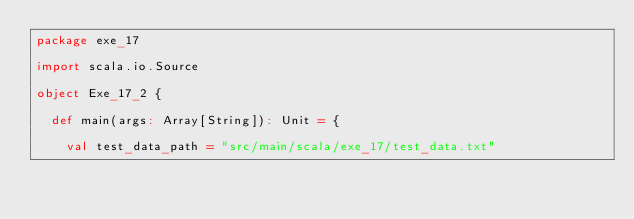Convert code to text. <code><loc_0><loc_0><loc_500><loc_500><_Scala_>package exe_17

import scala.io.Source

object Exe_17_2 {

  def main(args: Array[String]): Unit = {

    val test_data_path = "src/main/scala/exe_17/test_data.txt"</code> 